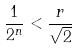<formula> <loc_0><loc_0><loc_500><loc_500>\frac { 1 } { 2 ^ { n } } < \frac { r } { \sqrt { 2 } }</formula> 